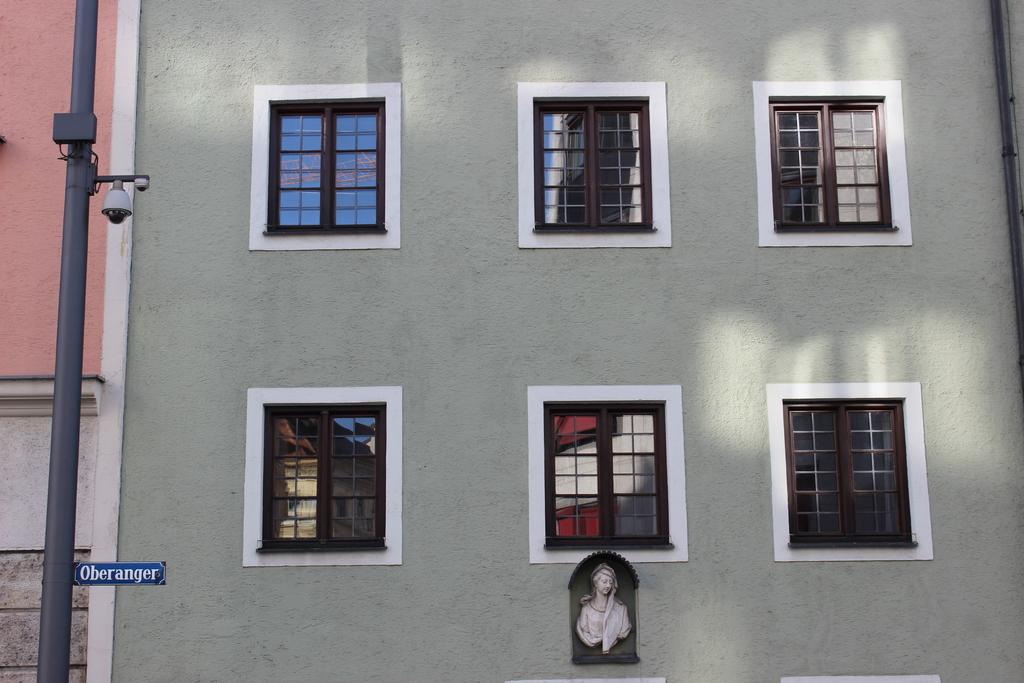What is the main subject of the image? There is a sculpture on a building in the image. What architectural features can be seen on the building? Windows are visible in the image. What other object is present in the image? There is a pole in the image. What type of illumination is present in the image? There are lights in the image. How many days have passed since the sculpture was placed on the ground in the image? The image does not show the sculpture on the ground, and there is no information about when it was placed. Additionally, the concept of days passing is not applicable to a static image. 